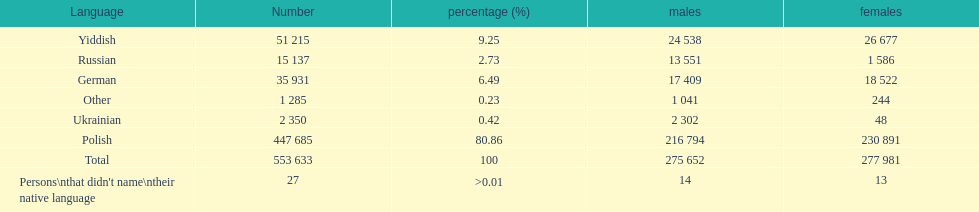Which language did only .42% of people in the imperial census of 1897 speak in the p&#322;ock governorate? Ukrainian. 